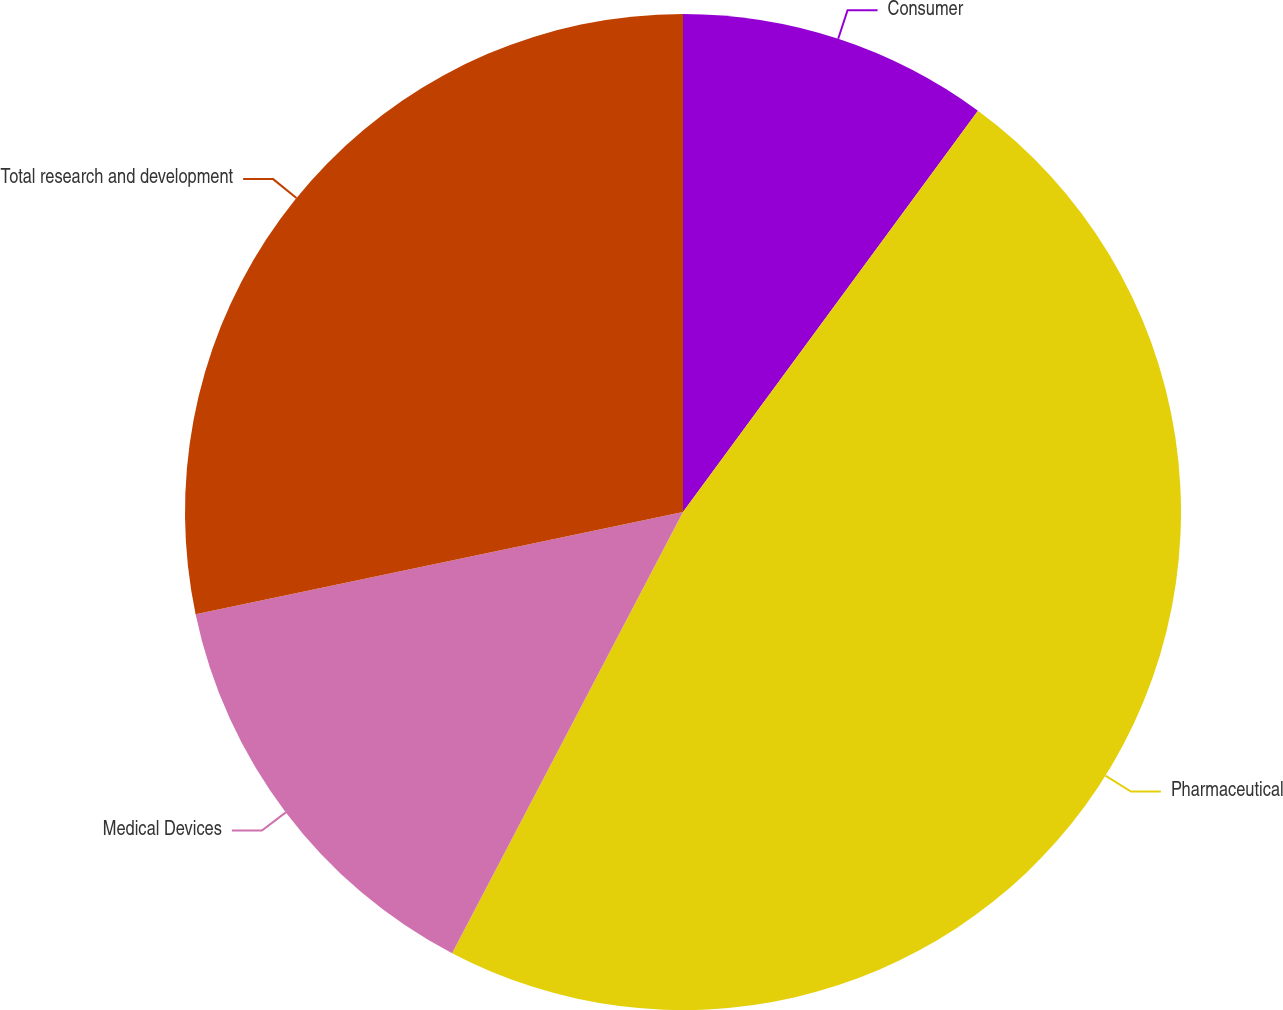Convert chart. <chart><loc_0><loc_0><loc_500><loc_500><pie_chart><fcel>Consumer<fcel>Pharmaceutical<fcel>Medical Devices<fcel>Total research and development<nl><fcel>10.09%<fcel>47.59%<fcel>14.04%<fcel>28.29%<nl></chart> 